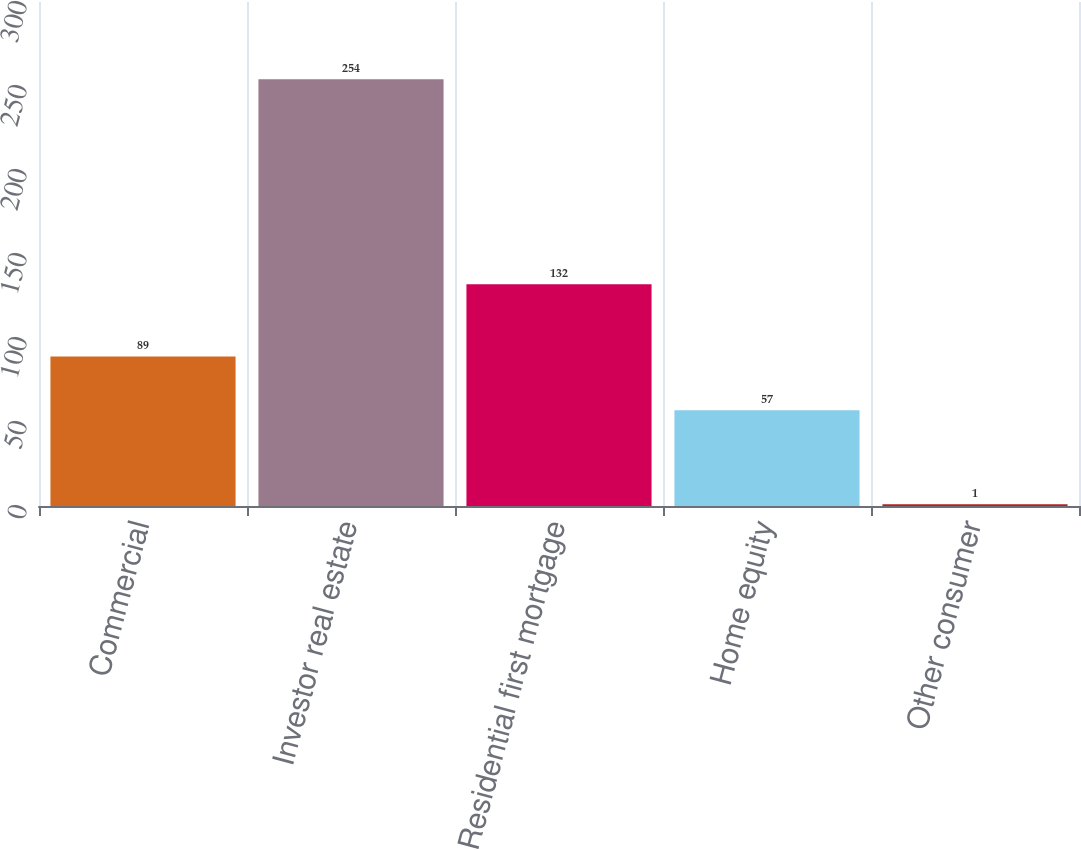<chart> <loc_0><loc_0><loc_500><loc_500><bar_chart><fcel>Commercial<fcel>Investor real estate<fcel>Residential first mortgage<fcel>Home equity<fcel>Other consumer<nl><fcel>89<fcel>254<fcel>132<fcel>57<fcel>1<nl></chart> 